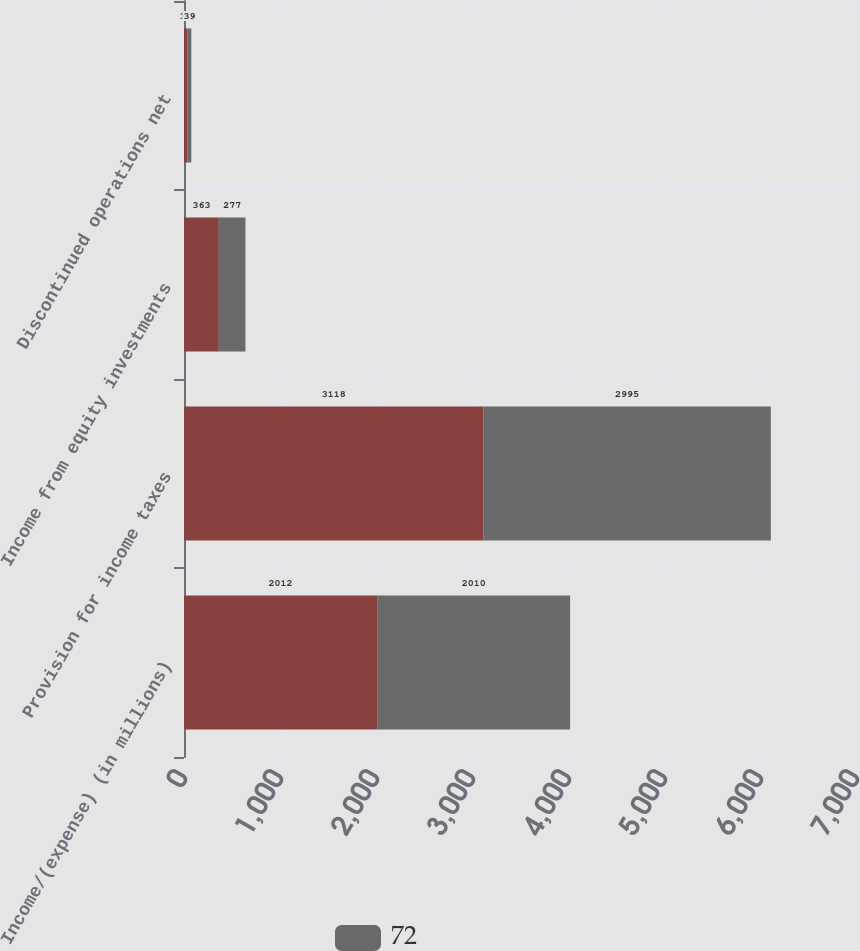<chart> <loc_0><loc_0><loc_500><loc_500><stacked_bar_chart><ecel><fcel>Income/(expense) (in millions)<fcel>Provision for income taxes<fcel>Income from equity investments<fcel>Discontinued operations net<nl><fcel>nan<fcel>2012<fcel>3118<fcel>363<fcel>37<nl><fcel>72<fcel>2010<fcel>2995<fcel>277<fcel>39<nl></chart> 